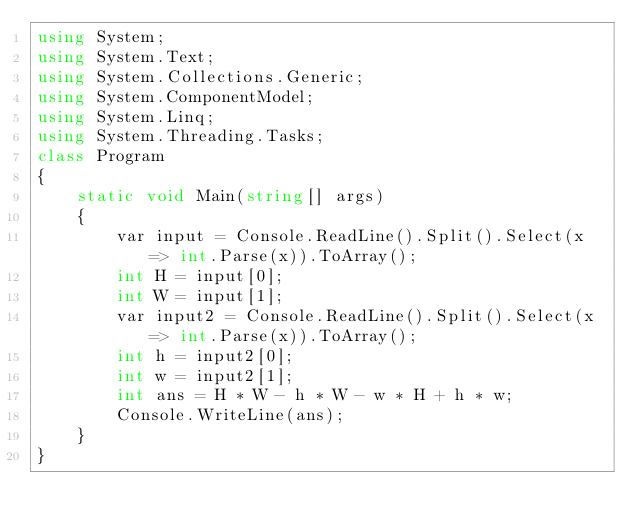<code> <loc_0><loc_0><loc_500><loc_500><_C#_>using System;
using System.Text;
using System.Collections.Generic;
using System.ComponentModel;
using System.Linq;
using System.Threading.Tasks;
class Program
{
	static void Main(string[] args)
	{
		var input = Console.ReadLine().Split().Select(x => int.Parse(x)).ToArray();
		int H = input[0];
		int W = input[1];
		var input2 = Console.ReadLine().Split().Select(x => int.Parse(x)).ToArray();
		int h = input2[0];
		int w = input2[1];
		int ans = H * W - h * W - w * H + h * w;
		Console.WriteLine(ans);
	}
}
</code> 